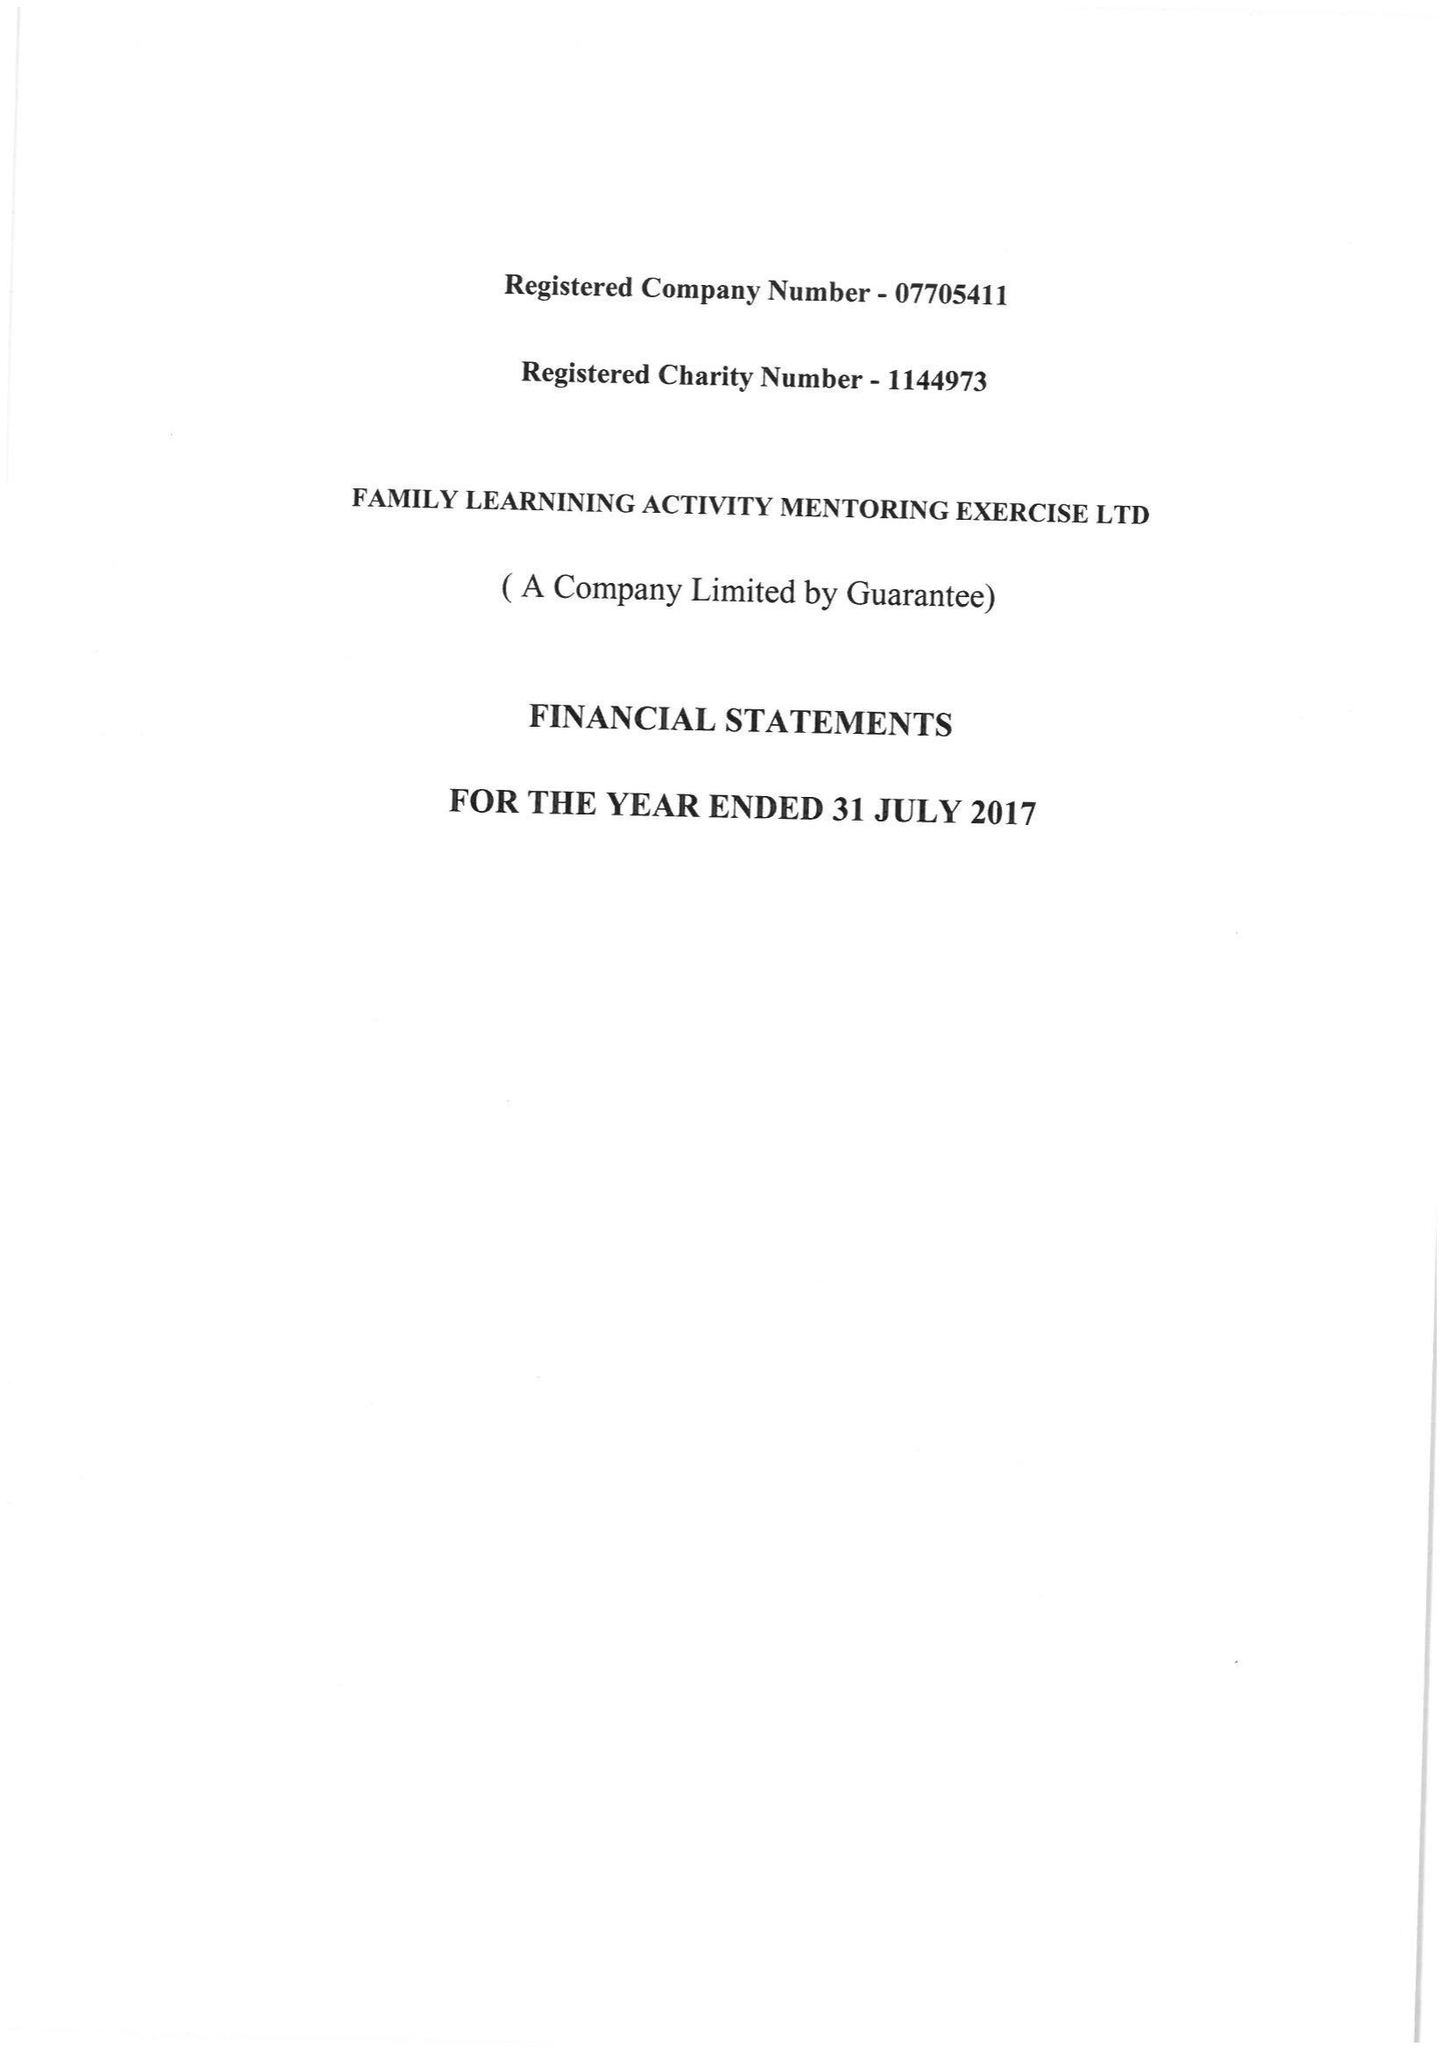What is the value for the spending_annually_in_british_pounds?
Answer the question using a single word or phrase. 10998.00 